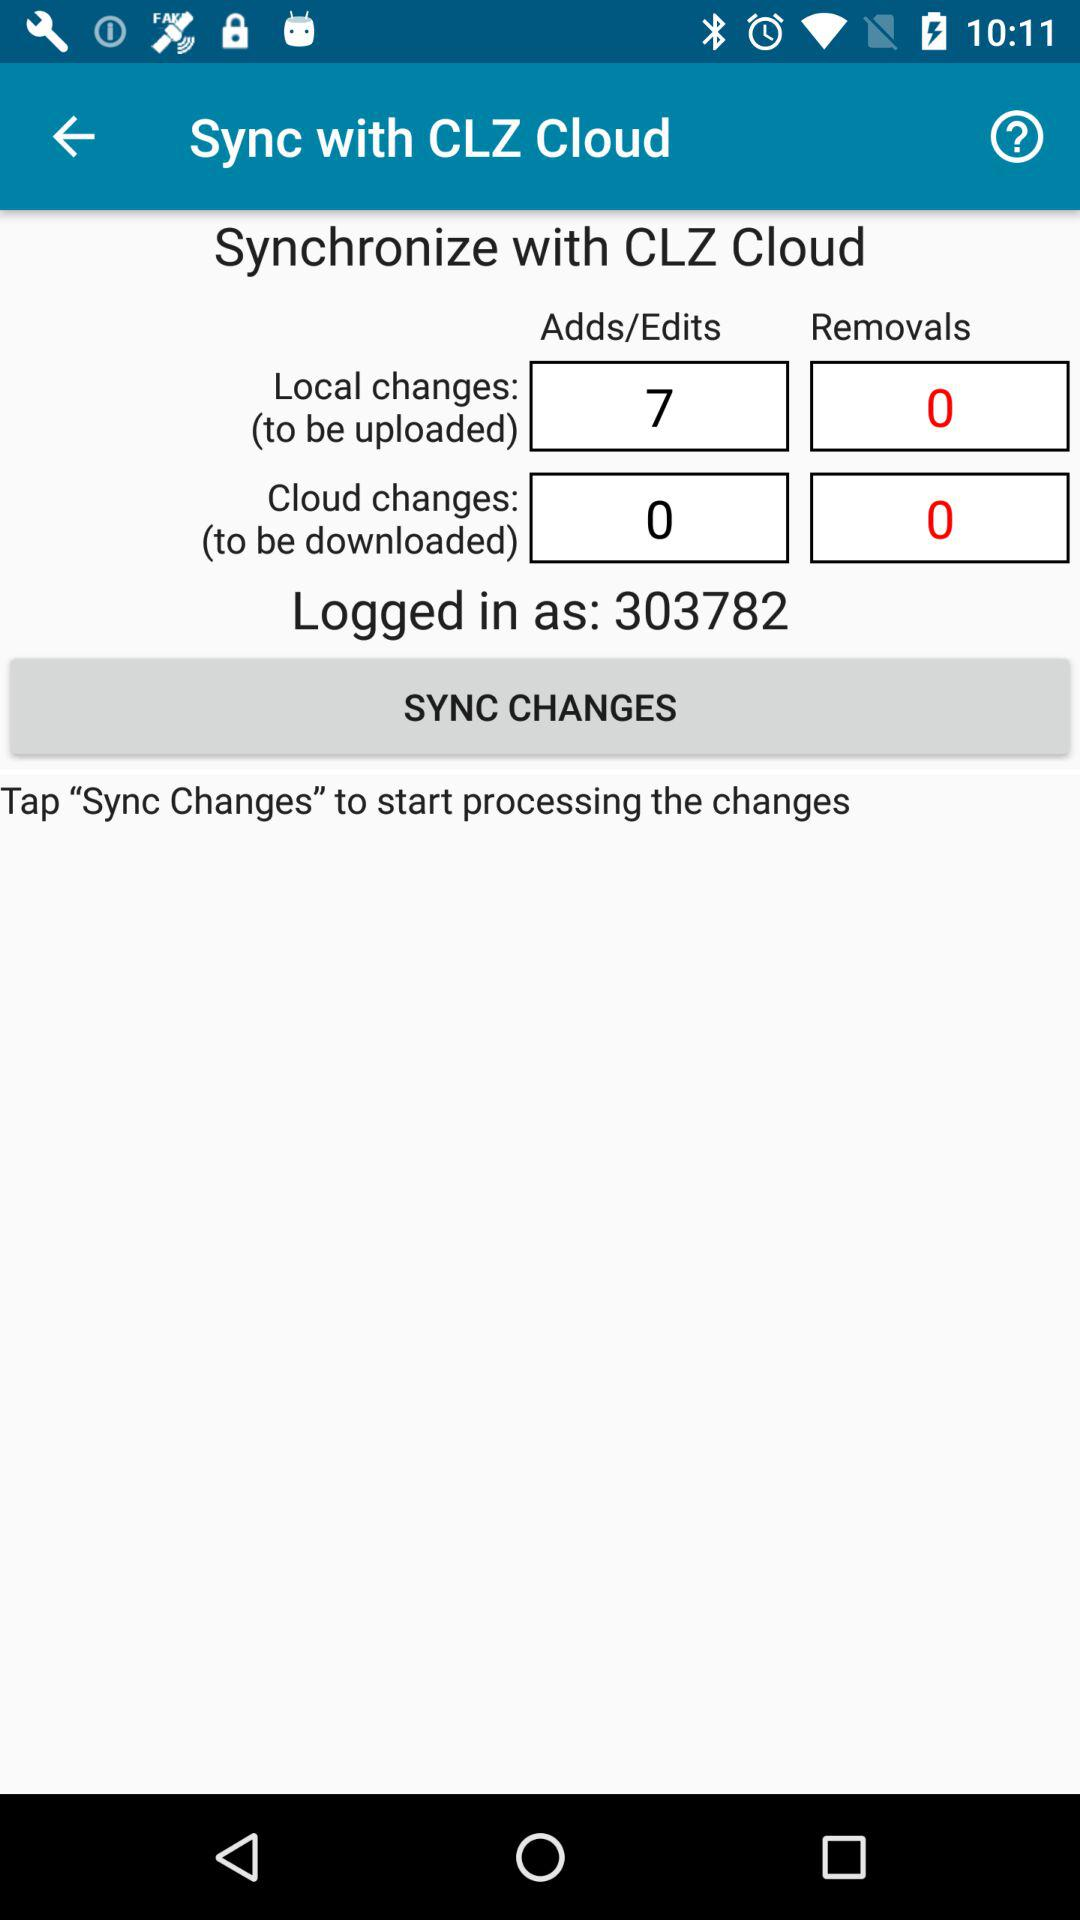Can you explain why it might be important to synchronize data with a cloud service? Certainly. Synchronizing data with a cloud service is essential for backup and data recovery purposes, ensuring information is preserved even if the local device encounters an issue. It also facilitates easy access to the data from different devices or locations, and helps in keeping the data updated across all user devices. 